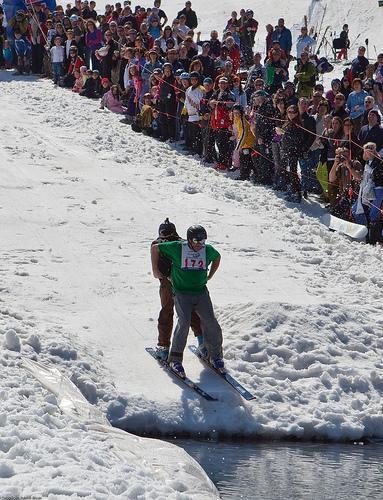How many people are skiing?
Give a very brief answer. 2. 